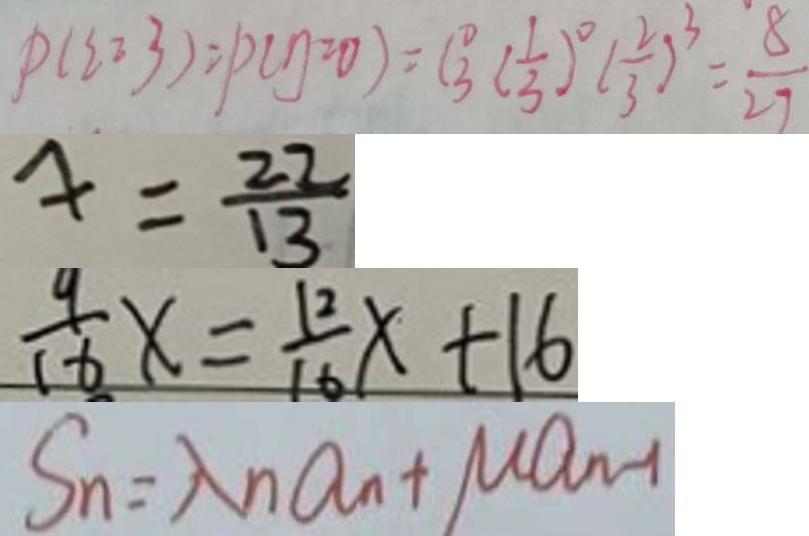Convert formula to latex. <formula><loc_0><loc_0><loc_500><loc_500>P ( \xi = 3 ) = p ( \eta = 0 ) = C \frac { 0 } { 3 } ( \frac { 1 } { 3 } ) ^ { 0 } ( \frac { 2 } { 3 } ) ^ { 3 } = \frac { 8 } { 2 7 } 
 4 = \frac { 2 2 } { 1 3 } 
 \frac { 9 } { 1 6 } x = \frac { 1 2 } { 1 6 } x + 1 6 
 S _ { n } = \lambda n a _ { n } + M a _ { n - 1 }</formula> 